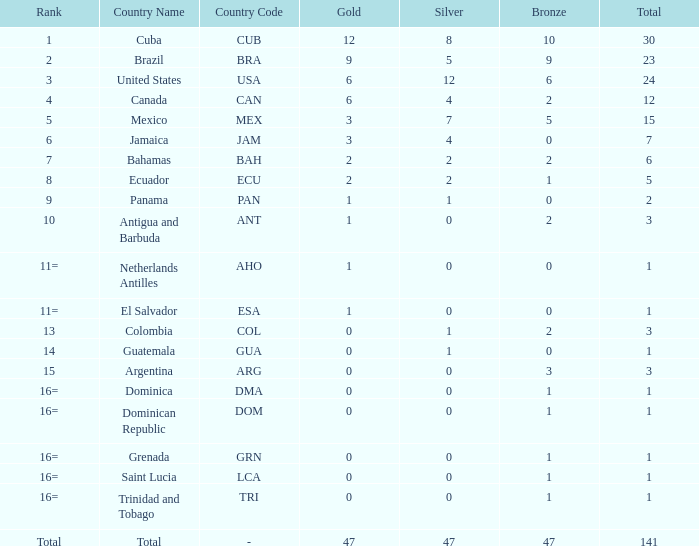How many bronzes have a Nation of jamaica (jam), and a Total smaller than 7? 0.0. 